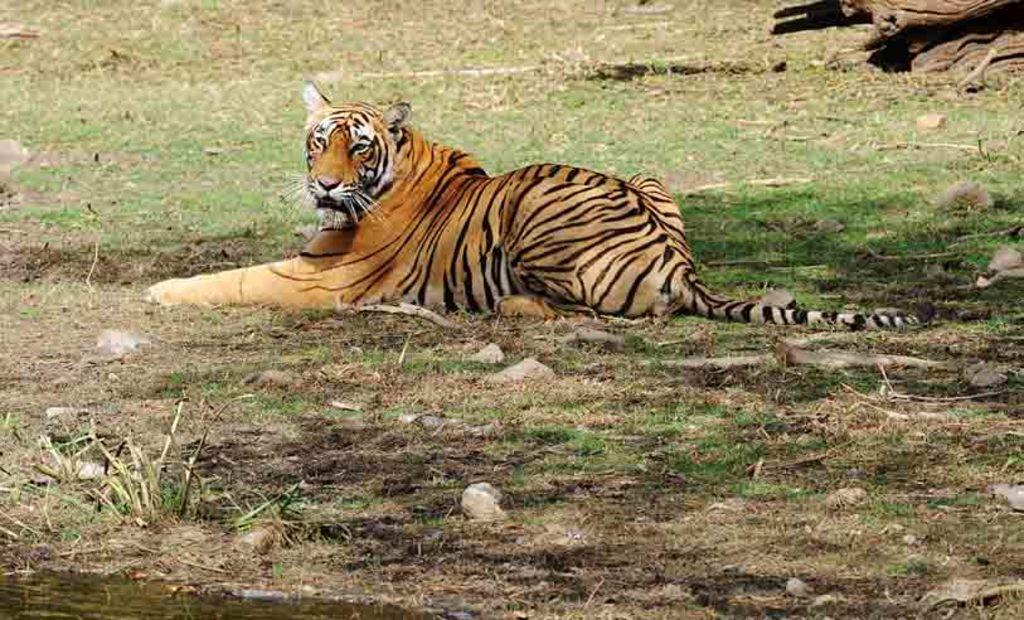What is visible in the image? Water and a tiger sitting on the grass are visible in the image. Can you describe the tiger's position in the image? The tiger is sitting on the grass in the image. What type of kite is being flown by the tiger in the image? There is no kite present in the image; it only features a tiger sitting on the grass. What type of destruction is being caused by the tiger in the image? There is no destruction being caused by the tiger in the image; the tiger is simply sitting on the grass. 